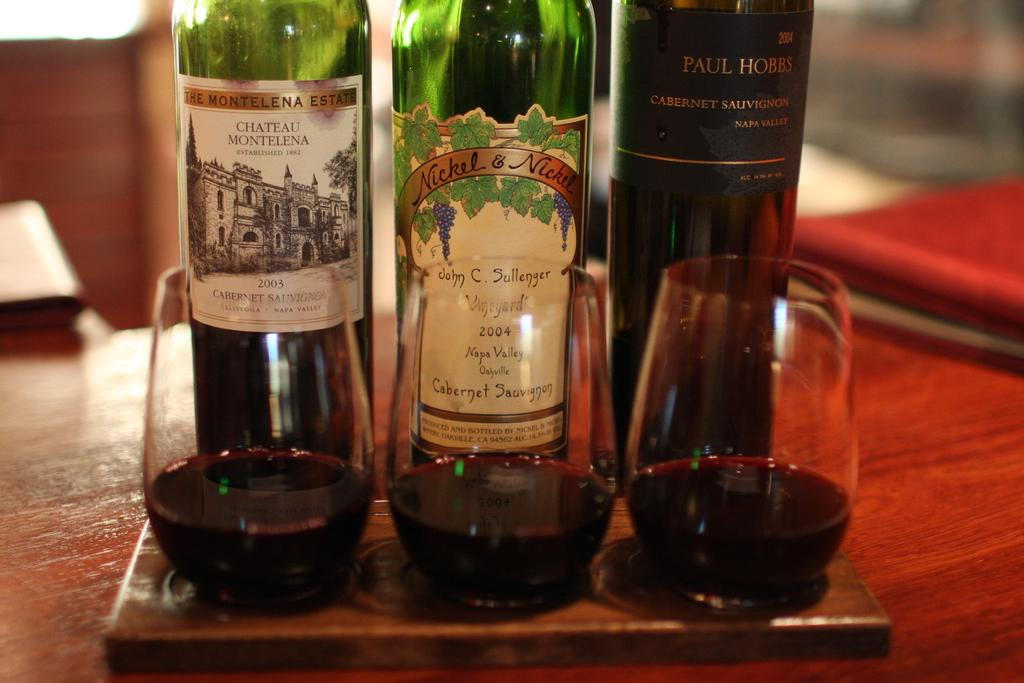<image>
Provide a brief description of the given image. A sample of 3 different cabernet sauvignon are being served on a small wooden board. 